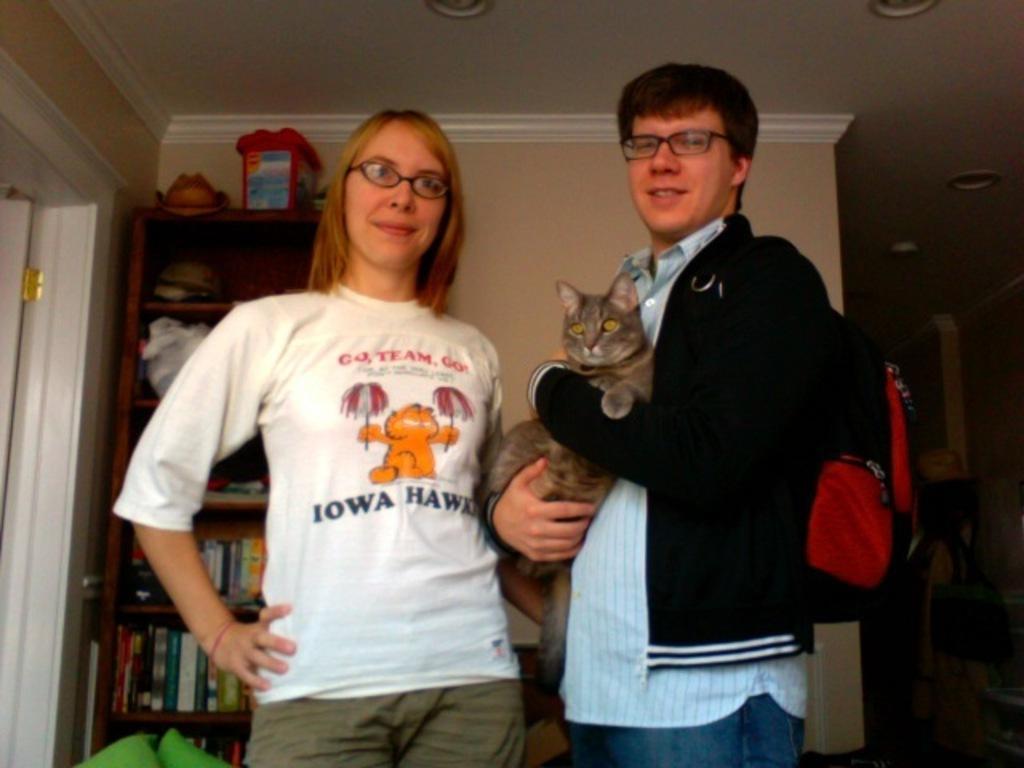In one or two sentences, can you explain what this image depicts? In this picture I can see couple of them standing and a man holding a cat with his hands and he is wearing a backpack and I can see few books and few items on the shelves. 